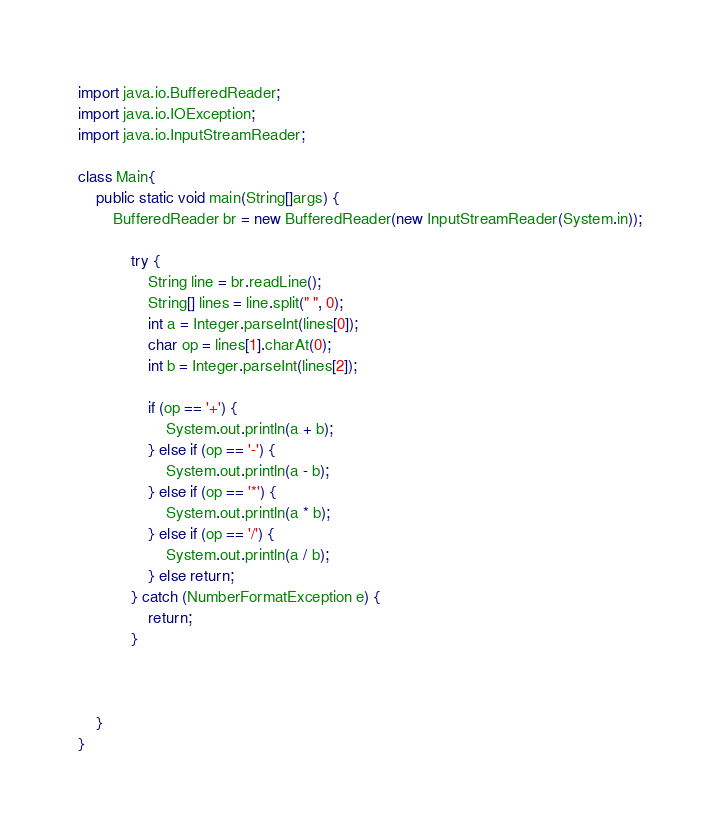Convert code to text. <code><loc_0><loc_0><loc_500><loc_500><_Java_>import java.io.BufferedReader;
import java.io.IOException;
import java.io.InputStreamReader;

class Main{
    public static void main(String[]args) {
        BufferedReader br = new BufferedReader(new InputStreamReader(System.in));

            try {
                String line = br.readLine();
                String[] lines = line.split(" ", 0);
                int a = Integer.parseInt(lines[0]);
                char op = lines[1].charAt(0);
                int b = Integer.parseInt(lines[2]);

                if (op == '+') {
                    System.out.println(a + b);
                } else if (op == '-') {
                    System.out.println(a - b);
                } else if (op == '*') {
                    System.out.println(a * b);
                } else if (op == '/') {
                    System.out.println(a / b);
                } else return;
            } catch (NumberFormatException e) {
                return;
            }



    }
}
</code> 